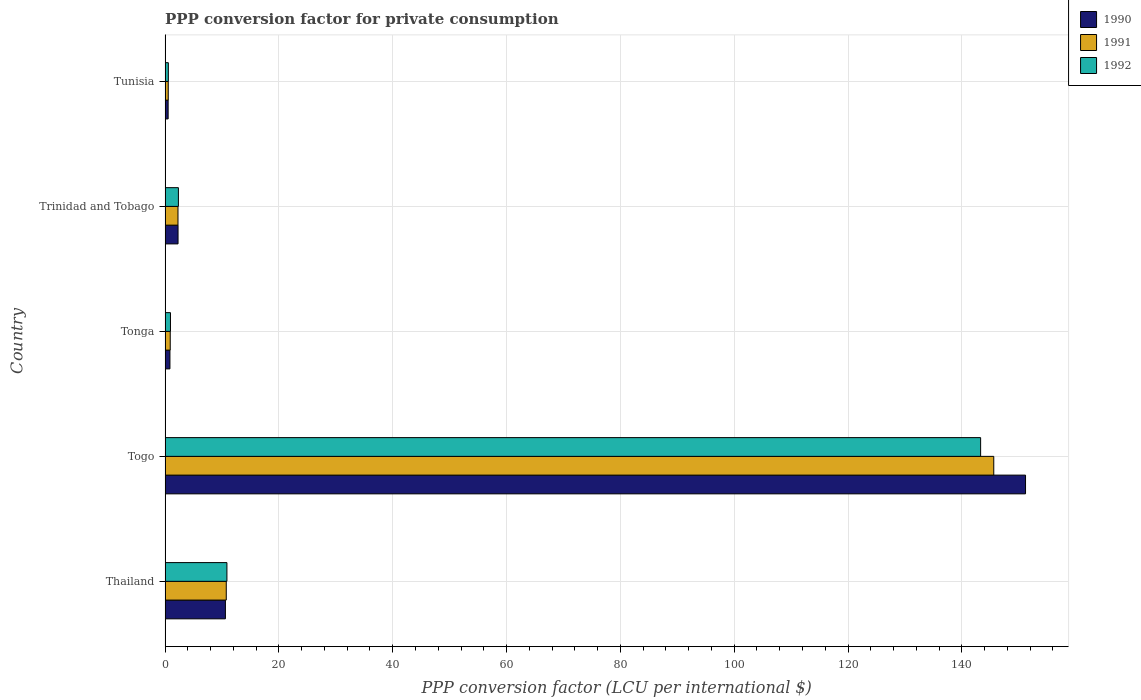How many groups of bars are there?
Make the answer very short. 5. What is the label of the 4th group of bars from the top?
Provide a short and direct response. Togo. What is the PPP conversion factor for private consumption in 1992 in Trinidad and Tobago?
Provide a short and direct response. 2.34. Across all countries, what is the maximum PPP conversion factor for private consumption in 1990?
Provide a short and direct response. 151.19. Across all countries, what is the minimum PPP conversion factor for private consumption in 1992?
Ensure brevity in your answer.  0.57. In which country was the PPP conversion factor for private consumption in 1991 maximum?
Ensure brevity in your answer.  Togo. In which country was the PPP conversion factor for private consumption in 1990 minimum?
Give a very brief answer. Tunisia. What is the total PPP conversion factor for private consumption in 1990 in the graph?
Offer a very short reply. 165.44. What is the difference between the PPP conversion factor for private consumption in 1991 in Togo and that in Trinidad and Tobago?
Make the answer very short. 143.34. What is the difference between the PPP conversion factor for private consumption in 1990 in Tunisia and the PPP conversion factor for private consumption in 1991 in Trinidad and Tobago?
Provide a succinct answer. -1.73. What is the average PPP conversion factor for private consumption in 1991 per country?
Offer a terse response. 32.02. What is the difference between the PPP conversion factor for private consumption in 1991 and PPP conversion factor for private consumption in 1992 in Thailand?
Your answer should be compact. -0.12. What is the ratio of the PPP conversion factor for private consumption in 1990 in Tonga to that in Trinidad and Tobago?
Offer a very short reply. 0.37. What is the difference between the highest and the second highest PPP conversion factor for private consumption in 1990?
Provide a succinct answer. 140.59. What is the difference between the highest and the lowest PPP conversion factor for private consumption in 1990?
Provide a short and direct response. 150.65. Is the sum of the PPP conversion factor for private consumption in 1991 in Togo and Tonga greater than the maximum PPP conversion factor for private consumption in 1992 across all countries?
Offer a very short reply. Yes. What does the 3rd bar from the bottom in Tonga represents?
Your response must be concise. 1992. Is it the case that in every country, the sum of the PPP conversion factor for private consumption in 1990 and PPP conversion factor for private consumption in 1991 is greater than the PPP conversion factor for private consumption in 1992?
Provide a short and direct response. Yes. How many countries are there in the graph?
Give a very brief answer. 5. Does the graph contain any zero values?
Provide a short and direct response. No. Does the graph contain grids?
Offer a very short reply. Yes. Where does the legend appear in the graph?
Provide a succinct answer. Top right. How many legend labels are there?
Your response must be concise. 3. What is the title of the graph?
Keep it short and to the point. PPP conversion factor for private consumption. Does "2008" appear as one of the legend labels in the graph?
Offer a very short reply. No. What is the label or title of the X-axis?
Your response must be concise. PPP conversion factor (LCU per international $). What is the label or title of the Y-axis?
Offer a very short reply. Country. What is the PPP conversion factor (LCU per international $) of 1990 in Thailand?
Provide a short and direct response. 10.6. What is the PPP conversion factor (LCU per international $) of 1991 in Thailand?
Provide a succinct answer. 10.75. What is the PPP conversion factor (LCU per international $) in 1992 in Thailand?
Keep it short and to the point. 10.86. What is the PPP conversion factor (LCU per international $) in 1990 in Togo?
Keep it short and to the point. 151.19. What is the PPP conversion factor (LCU per international $) in 1991 in Togo?
Provide a succinct answer. 145.61. What is the PPP conversion factor (LCU per international $) of 1992 in Togo?
Ensure brevity in your answer.  143.3. What is the PPP conversion factor (LCU per international $) in 1990 in Tonga?
Your answer should be compact. 0.85. What is the PPP conversion factor (LCU per international $) in 1991 in Tonga?
Your response must be concise. 0.9. What is the PPP conversion factor (LCU per international $) of 1992 in Tonga?
Your response must be concise. 0.94. What is the PPP conversion factor (LCU per international $) in 1990 in Trinidad and Tobago?
Provide a succinct answer. 2.27. What is the PPP conversion factor (LCU per international $) in 1991 in Trinidad and Tobago?
Your answer should be very brief. 2.26. What is the PPP conversion factor (LCU per international $) of 1992 in Trinidad and Tobago?
Provide a short and direct response. 2.34. What is the PPP conversion factor (LCU per international $) of 1990 in Tunisia?
Your answer should be compact. 0.53. What is the PPP conversion factor (LCU per international $) of 1991 in Tunisia?
Ensure brevity in your answer.  0.56. What is the PPP conversion factor (LCU per international $) in 1992 in Tunisia?
Provide a short and direct response. 0.57. Across all countries, what is the maximum PPP conversion factor (LCU per international $) of 1990?
Give a very brief answer. 151.19. Across all countries, what is the maximum PPP conversion factor (LCU per international $) in 1991?
Your answer should be compact. 145.61. Across all countries, what is the maximum PPP conversion factor (LCU per international $) of 1992?
Your answer should be very brief. 143.3. Across all countries, what is the minimum PPP conversion factor (LCU per international $) in 1990?
Give a very brief answer. 0.53. Across all countries, what is the minimum PPP conversion factor (LCU per international $) of 1991?
Give a very brief answer. 0.56. Across all countries, what is the minimum PPP conversion factor (LCU per international $) of 1992?
Offer a terse response. 0.57. What is the total PPP conversion factor (LCU per international $) of 1990 in the graph?
Offer a terse response. 165.44. What is the total PPP conversion factor (LCU per international $) of 1991 in the graph?
Your response must be concise. 160.08. What is the total PPP conversion factor (LCU per international $) in 1992 in the graph?
Keep it short and to the point. 158.01. What is the difference between the PPP conversion factor (LCU per international $) of 1990 in Thailand and that in Togo?
Keep it short and to the point. -140.59. What is the difference between the PPP conversion factor (LCU per international $) of 1991 in Thailand and that in Togo?
Provide a succinct answer. -134.86. What is the difference between the PPP conversion factor (LCU per international $) in 1992 in Thailand and that in Togo?
Provide a short and direct response. -132.43. What is the difference between the PPP conversion factor (LCU per international $) of 1990 in Thailand and that in Tonga?
Offer a very short reply. 9.75. What is the difference between the PPP conversion factor (LCU per international $) of 1991 in Thailand and that in Tonga?
Give a very brief answer. 9.85. What is the difference between the PPP conversion factor (LCU per international $) of 1992 in Thailand and that in Tonga?
Give a very brief answer. 9.92. What is the difference between the PPP conversion factor (LCU per international $) in 1990 in Thailand and that in Trinidad and Tobago?
Offer a very short reply. 8.32. What is the difference between the PPP conversion factor (LCU per international $) of 1991 in Thailand and that in Trinidad and Tobago?
Offer a very short reply. 8.48. What is the difference between the PPP conversion factor (LCU per international $) in 1992 in Thailand and that in Trinidad and Tobago?
Provide a succinct answer. 8.52. What is the difference between the PPP conversion factor (LCU per international $) in 1990 in Thailand and that in Tunisia?
Your answer should be very brief. 10.06. What is the difference between the PPP conversion factor (LCU per international $) in 1991 in Thailand and that in Tunisia?
Provide a succinct answer. 10.19. What is the difference between the PPP conversion factor (LCU per international $) in 1992 in Thailand and that in Tunisia?
Ensure brevity in your answer.  10.29. What is the difference between the PPP conversion factor (LCU per international $) in 1990 in Togo and that in Tonga?
Offer a terse response. 150.34. What is the difference between the PPP conversion factor (LCU per international $) in 1991 in Togo and that in Tonga?
Keep it short and to the point. 144.71. What is the difference between the PPP conversion factor (LCU per international $) in 1992 in Togo and that in Tonga?
Provide a short and direct response. 142.35. What is the difference between the PPP conversion factor (LCU per international $) in 1990 in Togo and that in Trinidad and Tobago?
Make the answer very short. 148.91. What is the difference between the PPP conversion factor (LCU per international $) of 1991 in Togo and that in Trinidad and Tobago?
Give a very brief answer. 143.34. What is the difference between the PPP conversion factor (LCU per international $) in 1992 in Togo and that in Trinidad and Tobago?
Your answer should be compact. 140.96. What is the difference between the PPP conversion factor (LCU per international $) in 1990 in Togo and that in Tunisia?
Provide a succinct answer. 150.65. What is the difference between the PPP conversion factor (LCU per international $) of 1991 in Togo and that in Tunisia?
Your answer should be compact. 145.05. What is the difference between the PPP conversion factor (LCU per international $) in 1992 in Togo and that in Tunisia?
Your answer should be very brief. 142.73. What is the difference between the PPP conversion factor (LCU per international $) of 1990 in Tonga and that in Trinidad and Tobago?
Give a very brief answer. -1.42. What is the difference between the PPP conversion factor (LCU per international $) in 1991 in Tonga and that in Trinidad and Tobago?
Your answer should be compact. -1.36. What is the difference between the PPP conversion factor (LCU per international $) of 1992 in Tonga and that in Trinidad and Tobago?
Offer a very short reply. -1.39. What is the difference between the PPP conversion factor (LCU per international $) of 1990 in Tonga and that in Tunisia?
Ensure brevity in your answer.  0.31. What is the difference between the PPP conversion factor (LCU per international $) in 1991 in Tonga and that in Tunisia?
Keep it short and to the point. 0.35. What is the difference between the PPP conversion factor (LCU per international $) of 1992 in Tonga and that in Tunisia?
Your answer should be very brief. 0.37. What is the difference between the PPP conversion factor (LCU per international $) in 1990 in Trinidad and Tobago and that in Tunisia?
Make the answer very short. 1.74. What is the difference between the PPP conversion factor (LCU per international $) in 1991 in Trinidad and Tobago and that in Tunisia?
Give a very brief answer. 1.71. What is the difference between the PPP conversion factor (LCU per international $) of 1992 in Trinidad and Tobago and that in Tunisia?
Keep it short and to the point. 1.77. What is the difference between the PPP conversion factor (LCU per international $) in 1990 in Thailand and the PPP conversion factor (LCU per international $) in 1991 in Togo?
Offer a very short reply. -135.01. What is the difference between the PPP conversion factor (LCU per international $) of 1990 in Thailand and the PPP conversion factor (LCU per international $) of 1992 in Togo?
Your answer should be compact. -132.7. What is the difference between the PPP conversion factor (LCU per international $) in 1991 in Thailand and the PPP conversion factor (LCU per international $) in 1992 in Togo?
Your answer should be very brief. -132.55. What is the difference between the PPP conversion factor (LCU per international $) in 1990 in Thailand and the PPP conversion factor (LCU per international $) in 1991 in Tonga?
Your response must be concise. 9.7. What is the difference between the PPP conversion factor (LCU per international $) of 1990 in Thailand and the PPP conversion factor (LCU per international $) of 1992 in Tonga?
Provide a succinct answer. 9.65. What is the difference between the PPP conversion factor (LCU per international $) of 1991 in Thailand and the PPP conversion factor (LCU per international $) of 1992 in Tonga?
Ensure brevity in your answer.  9.8. What is the difference between the PPP conversion factor (LCU per international $) of 1990 in Thailand and the PPP conversion factor (LCU per international $) of 1991 in Trinidad and Tobago?
Keep it short and to the point. 8.33. What is the difference between the PPP conversion factor (LCU per international $) in 1990 in Thailand and the PPP conversion factor (LCU per international $) in 1992 in Trinidad and Tobago?
Your answer should be compact. 8.26. What is the difference between the PPP conversion factor (LCU per international $) of 1991 in Thailand and the PPP conversion factor (LCU per international $) of 1992 in Trinidad and Tobago?
Your answer should be compact. 8.41. What is the difference between the PPP conversion factor (LCU per international $) in 1990 in Thailand and the PPP conversion factor (LCU per international $) in 1991 in Tunisia?
Offer a very short reply. 10.04. What is the difference between the PPP conversion factor (LCU per international $) of 1990 in Thailand and the PPP conversion factor (LCU per international $) of 1992 in Tunisia?
Provide a succinct answer. 10.03. What is the difference between the PPP conversion factor (LCU per international $) in 1991 in Thailand and the PPP conversion factor (LCU per international $) in 1992 in Tunisia?
Your answer should be compact. 10.18. What is the difference between the PPP conversion factor (LCU per international $) of 1990 in Togo and the PPP conversion factor (LCU per international $) of 1991 in Tonga?
Your response must be concise. 150.29. What is the difference between the PPP conversion factor (LCU per international $) of 1990 in Togo and the PPP conversion factor (LCU per international $) of 1992 in Tonga?
Provide a succinct answer. 150.24. What is the difference between the PPP conversion factor (LCU per international $) in 1991 in Togo and the PPP conversion factor (LCU per international $) in 1992 in Tonga?
Your response must be concise. 144.66. What is the difference between the PPP conversion factor (LCU per international $) of 1990 in Togo and the PPP conversion factor (LCU per international $) of 1991 in Trinidad and Tobago?
Ensure brevity in your answer.  148.92. What is the difference between the PPP conversion factor (LCU per international $) in 1990 in Togo and the PPP conversion factor (LCU per international $) in 1992 in Trinidad and Tobago?
Keep it short and to the point. 148.85. What is the difference between the PPP conversion factor (LCU per international $) of 1991 in Togo and the PPP conversion factor (LCU per international $) of 1992 in Trinidad and Tobago?
Your answer should be very brief. 143.27. What is the difference between the PPP conversion factor (LCU per international $) of 1990 in Togo and the PPP conversion factor (LCU per international $) of 1991 in Tunisia?
Offer a terse response. 150.63. What is the difference between the PPP conversion factor (LCU per international $) in 1990 in Togo and the PPP conversion factor (LCU per international $) in 1992 in Tunisia?
Provide a succinct answer. 150.62. What is the difference between the PPP conversion factor (LCU per international $) in 1991 in Togo and the PPP conversion factor (LCU per international $) in 1992 in Tunisia?
Make the answer very short. 145.04. What is the difference between the PPP conversion factor (LCU per international $) in 1990 in Tonga and the PPP conversion factor (LCU per international $) in 1991 in Trinidad and Tobago?
Make the answer very short. -1.41. What is the difference between the PPP conversion factor (LCU per international $) in 1990 in Tonga and the PPP conversion factor (LCU per international $) in 1992 in Trinidad and Tobago?
Your response must be concise. -1.49. What is the difference between the PPP conversion factor (LCU per international $) of 1991 in Tonga and the PPP conversion factor (LCU per international $) of 1992 in Trinidad and Tobago?
Make the answer very short. -1.44. What is the difference between the PPP conversion factor (LCU per international $) in 1990 in Tonga and the PPP conversion factor (LCU per international $) in 1991 in Tunisia?
Your answer should be compact. 0.29. What is the difference between the PPP conversion factor (LCU per international $) of 1990 in Tonga and the PPP conversion factor (LCU per international $) of 1992 in Tunisia?
Provide a succinct answer. 0.28. What is the difference between the PPP conversion factor (LCU per international $) of 1991 in Tonga and the PPP conversion factor (LCU per international $) of 1992 in Tunisia?
Give a very brief answer. 0.33. What is the difference between the PPP conversion factor (LCU per international $) in 1990 in Trinidad and Tobago and the PPP conversion factor (LCU per international $) in 1991 in Tunisia?
Give a very brief answer. 1.72. What is the difference between the PPP conversion factor (LCU per international $) in 1990 in Trinidad and Tobago and the PPP conversion factor (LCU per international $) in 1992 in Tunisia?
Provide a succinct answer. 1.7. What is the difference between the PPP conversion factor (LCU per international $) of 1991 in Trinidad and Tobago and the PPP conversion factor (LCU per international $) of 1992 in Tunisia?
Keep it short and to the point. 1.69. What is the average PPP conversion factor (LCU per international $) in 1990 per country?
Your answer should be compact. 33.09. What is the average PPP conversion factor (LCU per international $) in 1991 per country?
Offer a terse response. 32.02. What is the average PPP conversion factor (LCU per international $) in 1992 per country?
Make the answer very short. 31.6. What is the difference between the PPP conversion factor (LCU per international $) of 1990 and PPP conversion factor (LCU per international $) of 1991 in Thailand?
Your answer should be compact. -0.15. What is the difference between the PPP conversion factor (LCU per international $) of 1990 and PPP conversion factor (LCU per international $) of 1992 in Thailand?
Your answer should be compact. -0.27. What is the difference between the PPP conversion factor (LCU per international $) in 1991 and PPP conversion factor (LCU per international $) in 1992 in Thailand?
Your answer should be compact. -0.12. What is the difference between the PPP conversion factor (LCU per international $) of 1990 and PPP conversion factor (LCU per international $) of 1991 in Togo?
Provide a succinct answer. 5.58. What is the difference between the PPP conversion factor (LCU per international $) in 1990 and PPP conversion factor (LCU per international $) in 1992 in Togo?
Your response must be concise. 7.89. What is the difference between the PPP conversion factor (LCU per international $) in 1991 and PPP conversion factor (LCU per international $) in 1992 in Togo?
Your response must be concise. 2.31. What is the difference between the PPP conversion factor (LCU per international $) in 1990 and PPP conversion factor (LCU per international $) in 1991 in Tonga?
Provide a short and direct response. -0.05. What is the difference between the PPP conversion factor (LCU per international $) in 1990 and PPP conversion factor (LCU per international $) in 1992 in Tonga?
Give a very brief answer. -0.09. What is the difference between the PPP conversion factor (LCU per international $) in 1991 and PPP conversion factor (LCU per international $) in 1992 in Tonga?
Offer a terse response. -0.04. What is the difference between the PPP conversion factor (LCU per international $) in 1990 and PPP conversion factor (LCU per international $) in 1991 in Trinidad and Tobago?
Make the answer very short. 0.01. What is the difference between the PPP conversion factor (LCU per international $) in 1990 and PPP conversion factor (LCU per international $) in 1992 in Trinidad and Tobago?
Offer a very short reply. -0.07. What is the difference between the PPP conversion factor (LCU per international $) of 1991 and PPP conversion factor (LCU per international $) of 1992 in Trinidad and Tobago?
Provide a succinct answer. -0.07. What is the difference between the PPP conversion factor (LCU per international $) of 1990 and PPP conversion factor (LCU per international $) of 1991 in Tunisia?
Provide a succinct answer. -0.02. What is the difference between the PPP conversion factor (LCU per international $) in 1990 and PPP conversion factor (LCU per international $) in 1992 in Tunisia?
Give a very brief answer. -0.04. What is the difference between the PPP conversion factor (LCU per international $) in 1991 and PPP conversion factor (LCU per international $) in 1992 in Tunisia?
Provide a short and direct response. -0.02. What is the ratio of the PPP conversion factor (LCU per international $) of 1990 in Thailand to that in Togo?
Offer a terse response. 0.07. What is the ratio of the PPP conversion factor (LCU per international $) in 1991 in Thailand to that in Togo?
Keep it short and to the point. 0.07. What is the ratio of the PPP conversion factor (LCU per international $) of 1992 in Thailand to that in Togo?
Offer a terse response. 0.08. What is the ratio of the PPP conversion factor (LCU per international $) in 1990 in Thailand to that in Tonga?
Give a very brief answer. 12.47. What is the ratio of the PPP conversion factor (LCU per international $) in 1991 in Thailand to that in Tonga?
Your response must be concise. 11.92. What is the ratio of the PPP conversion factor (LCU per international $) of 1992 in Thailand to that in Tonga?
Make the answer very short. 11.5. What is the ratio of the PPP conversion factor (LCU per international $) of 1990 in Thailand to that in Trinidad and Tobago?
Make the answer very short. 4.66. What is the ratio of the PPP conversion factor (LCU per international $) of 1991 in Thailand to that in Trinidad and Tobago?
Ensure brevity in your answer.  4.75. What is the ratio of the PPP conversion factor (LCU per international $) of 1992 in Thailand to that in Trinidad and Tobago?
Ensure brevity in your answer.  4.64. What is the ratio of the PPP conversion factor (LCU per international $) of 1990 in Thailand to that in Tunisia?
Your answer should be very brief. 19.81. What is the ratio of the PPP conversion factor (LCU per international $) in 1991 in Thailand to that in Tunisia?
Provide a succinct answer. 19.36. What is the ratio of the PPP conversion factor (LCU per international $) in 1992 in Thailand to that in Tunisia?
Offer a very short reply. 19.05. What is the ratio of the PPP conversion factor (LCU per international $) in 1990 in Togo to that in Tonga?
Your response must be concise. 177.93. What is the ratio of the PPP conversion factor (LCU per international $) in 1991 in Togo to that in Tonga?
Give a very brief answer. 161.51. What is the ratio of the PPP conversion factor (LCU per international $) of 1992 in Togo to that in Tonga?
Keep it short and to the point. 151.72. What is the ratio of the PPP conversion factor (LCU per international $) in 1990 in Togo to that in Trinidad and Tobago?
Ensure brevity in your answer.  66.48. What is the ratio of the PPP conversion factor (LCU per international $) in 1991 in Togo to that in Trinidad and Tobago?
Provide a succinct answer. 64.31. What is the ratio of the PPP conversion factor (LCU per international $) in 1992 in Togo to that in Trinidad and Tobago?
Your answer should be compact. 61.26. What is the ratio of the PPP conversion factor (LCU per international $) of 1990 in Togo to that in Tunisia?
Offer a very short reply. 282.64. What is the ratio of the PPP conversion factor (LCU per international $) of 1991 in Togo to that in Tunisia?
Provide a succinct answer. 262.25. What is the ratio of the PPP conversion factor (LCU per international $) in 1992 in Togo to that in Tunisia?
Give a very brief answer. 251.27. What is the ratio of the PPP conversion factor (LCU per international $) in 1990 in Tonga to that in Trinidad and Tobago?
Your answer should be compact. 0.37. What is the ratio of the PPP conversion factor (LCU per international $) in 1991 in Tonga to that in Trinidad and Tobago?
Your answer should be very brief. 0.4. What is the ratio of the PPP conversion factor (LCU per international $) in 1992 in Tonga to that in Trinidad and Tobago?
Offer a very short reply. 0.4. What is the ratio of the PPP conversion factor (LCU per international $) in 1990 in Tonga to that in Tunisia?
Offer a terse response. 1.59. What is the ratio of the PPP conversion factor (LCU per international $) in 1991 in Tonga to that in Tunisia?
Make the answer very short. 1.62. What is the ratio of the PPP conversion factor (LCU per international $) in 1992 in Tonga to that in Tunisia?
Your response must be concise. 1.66. What is the ratio of the PPP conversion factor (LCU per international $) in 1990 in Trinidad and Tobago to that in Tunisia?
Offer a terse response. 4.25. What is the ratio of the PPP conversion factor (LCU per international $) of 1991 in Trinidad and Tobago to that in Tunisia?
Provide a succinct answer. 4.08. What is the ratio of the PPP conversion factor (LCU per international $) in 1992 in Trinidad and Tobago to that in Tunisia?
Provide a succinct answer. 4.1. What is the difference between the highest and the second highest PPP conversion factor (LCU per international $) in 1990?
Your answer should be compact. 140.59. What is the difference between the highest and the second highest PPP conversion factor (LCU per international $) of 1991?
Provide a short and direct response. 134.86. What is the difference between the highest and the second highest PPP conversion factor (LCU per international $) of 1992?
Make the answer very short. 132.43. What is the difference between the highest and the lowest PPP conversion factor (LCU per international $) of 1990?
Offer a very short reply. 150.65. What is the difference between the highest and the lowest PPP conversion factor (LCU per international $) in 1991?
Offer a terse response. 145.05. What is the difference between the highest and the lowest PPP conversion factor (LCU per international $) of 1992?
Provide a short and direct response. 142.73. 